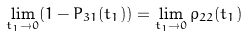Convert formula to latex. <formula><loc_0><loc_0><loc_500><loc_500>\lim _ { t _ { 1 } \rightarrow 0 } ( 1 - P _ { 3 1 } ( t _ { 1 } ) ) = \lim _ { t _ { 1 } \rightarrow 0 } \rho _ { 2 2 } ( t _ { 1 } )</formula> 